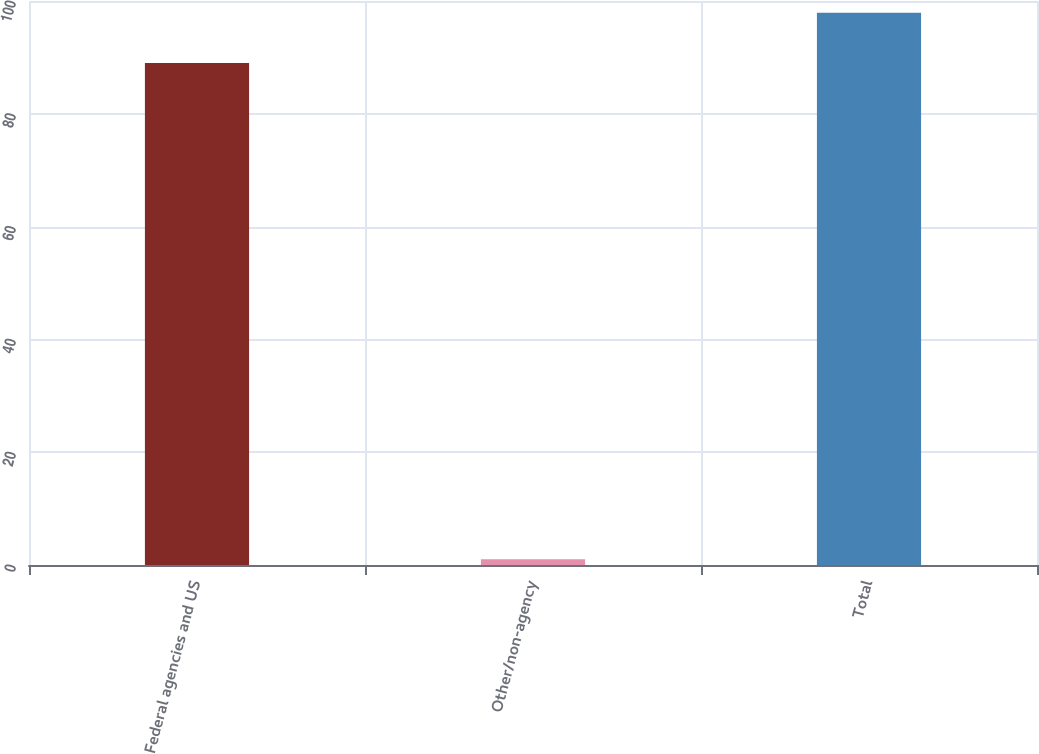Convert chart to OTSL. <chart><loc_0><loc_0><loc_500><loc_500><bar_chart><fcel>Federal agencies and US<fcel>Other/non-agency<fcel>Total<nl><fcel>89<fcel>1<fcel>97.9<nl></chart> 